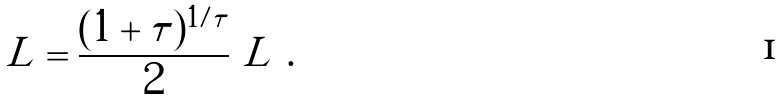Convert formula to latex. <formula><loc_0><loc_0><loc_500><loc_500>\tilde { L } = \frac { ( 1 + \tau ) ^ { 1 / \tau } } { 2 } \ L \ .</formula> 